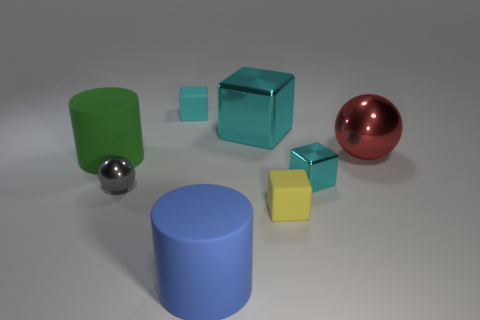How many large rubber cylinders are right of the small rubber thing that is in front of the big cyan metallic thing?
Offer a terse response. 0. How many things are either small matte things behind the tiny cyan shiny object or small cyan shiny objects?
Ensure brevity in your answer.  2. How many tiny cubes are the same material as the big red ball?
Keep it short and to the point. 1. What shape is the large metal object that is the same color as the small metal cube?
Your answer should be compact. Cube. Are there an equal number of red spheres right of the green thing and yellow things?
Offer a very short reply. Yes. How big is the sphere on the right side of the cyan matte block?
Provide a short and direct response. Large. How many large objects are either gray metallic things or cyan rubber objects?
Provide a short and direct response. 0. There is another matte object that is the same shape as the blue matte object; what is its color?
Your answer should be compact. Green. Do the green cylinder and the gray metallic sphere have the same size?
Make the answer very short. No. How many things are either big green matte things or yellow matte things that are right of the gray metal thing?
Your answer should be very brief. 2. 